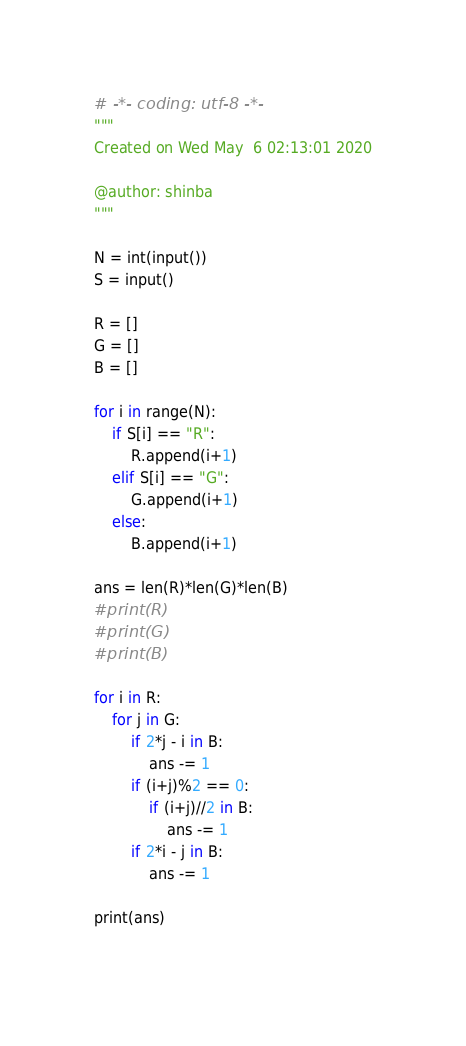Convert code to text. <code><loc_0><loc_0><loc_500><loc_500><_Python_># -*- coding: utf-8 -*-
"""
Created on Wed May  6 02:13:01 2020

@author: shinba
"""

N = int(input())
S = input()

R = []
G = []
B = []

for i in range(N):
    if S[i] == "R":
        R.append(i+1)
    elif S[i] == "G":
        G.append(i+1)
    else:
        B.append(i+1)

ans = len(R)*len(G)*len(B)
#print(R)
#print(G)
#print(B)

for i in R:
    for j in G:
        if 2*j - i in B:
            ans -= 1
        if (i+j)%2 == 0:
            if (i+j)//2 in B:
                ans -= 1
        if 2*i - j in B:
            ans -= 1

print(ans)
        
</code> 